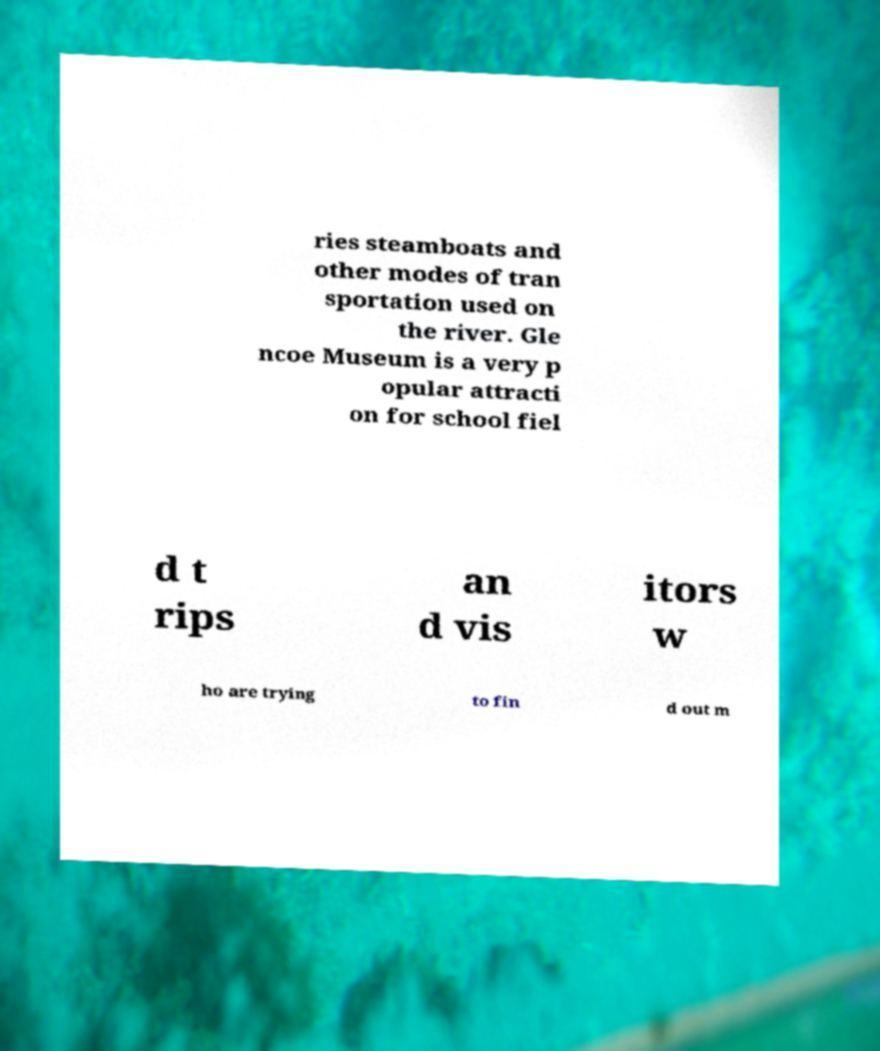I need the written content from this picture converted into text. Can you do that? ries steamboats and other modes of tran sportation used on the river. Gle ncoe Museum is a very p opular attracti on for school fiel d t rips an d vis itors w ho are trying to fin d out m 